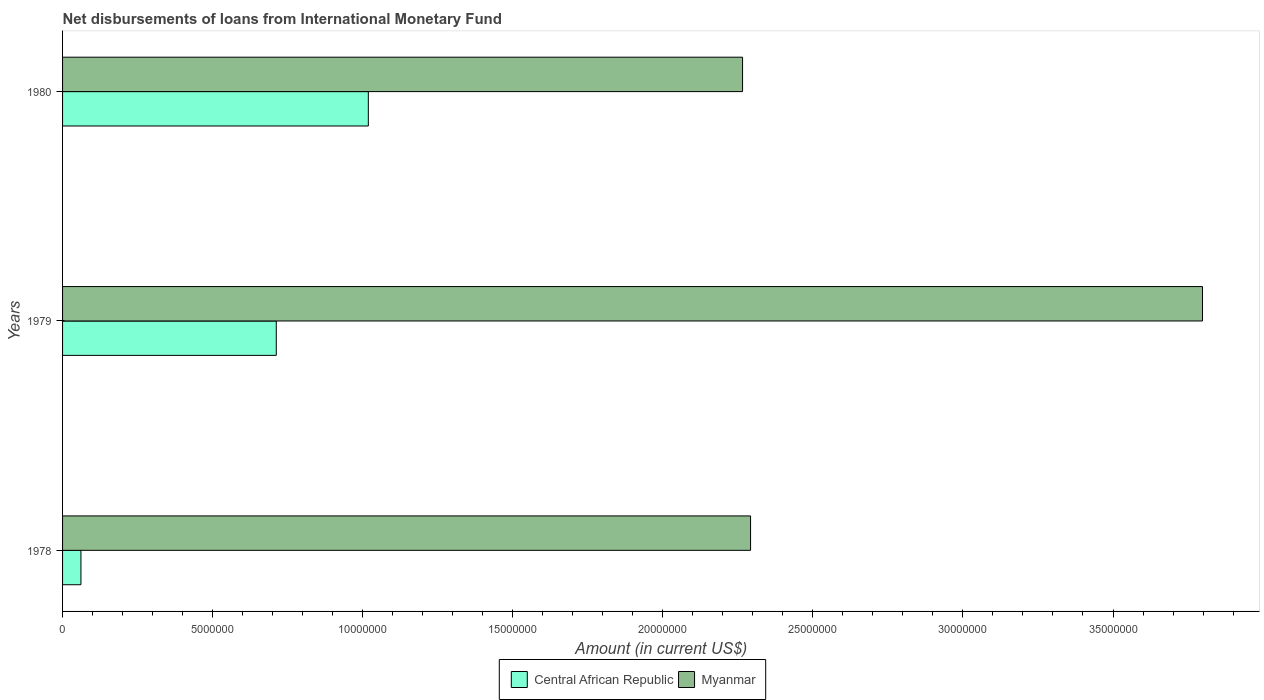How many groups of bars are there?
Offer a terse response. 3. How many bars are there on the 3rd tick from the bottom?
Provide a succinct answer. 2. What is the label of the 2nd group of bars from the top?
Offer a very short reply. 1979. What is the amount of loans disbursed in Central African Republic in 1978?
Your answer should be very brief. 6.12e+05. Across all years, what is the maximum amount of loans disbursed in Central African Republic?
Give a very brief answer. 1.02e+07. Across all years, what is the minimum amount of loans disbursed in Myanmar?
Offer a terse response. 2.27e+07. In which year was the amount of loans disbursed in Myanmar maximum?
Offer a very short reply. 1979. What is the total amount of loans disbursed in Central African Republic in the graph?
Your answer should be compact. 1.79e+07. What is the difference between the amount of loans disbursed in Myanmar in 1978 and that in 1979?
Provide a short and direct response. -1.51e+07. What is the difference between the amount of loans disbursed in Myanmar in 1980 and the amount of loans disbursed in Central African Republic in 1979?
Your answer should be very brief. 1.55e+07. What is the average amount of loans disbursed in Myanmar per year?
Give a very brief answer. 2.79e+07. In the year 1978, what is the difference between the amount of loans disbursed in Central African Republic and amount of loans disbursed in Myanmar?
Provide a short and direct response. -2.23e+07. In how many years, is the amount of loans disbursed in Myanmar greater than 30000000 US$?
Your answer should be compact. 1. What is the ratio of the amount of loans disbursed in Myanmar in 1978 to that in 1980?
Offer a very short reply. 1.01. What is the difference between the highest and the second highest amount of loans disbursed in Myanmar?
Offer a terse response. 1.51e+07. What is the difference between the highest and the lowest amount of loans disbursed in Central African Republic?
Provide a short and direct response. 9.58e+06. Is the sum of the amount of loans disbursed in Central African Republic in 1979 and 1980 greater than the maximum amount of loans disbursed in Myanmar across all years?
Offer a very short reply. No. What does the 2nd bar from the top in 1979 represents?
Provide a short and direct response. Central African Republic. What does the 2nd bar from the bottom in 1979 represents?
Your answer should be very brief. Myanmar. How many bars are there?
Make the answer very short. 6. Are all the bars in the graph horizontal?
Ensure brevity in your answer.  Yes. Are the values on the major ticks of X-axis written in scientific E-notation?
Give a very brief answer. No. Does the graph contain any zero values?
Provide a short and direct response. No. Does the graph contain grids?
Offer a terse response. No. How many legend labels are there?
Give a very brief answer. 2. How are the legend labels stacked?
Make the answer very short. Horizontal. What is the title of the graph?
Your answer should be very brief. Net disbursements of loans from International Monetary Fund. Does "Arab World" appear as one of the legend labels in the graph?
Make the answer very short. No. What is the label or title of the X-axis?
Your answer should be very brief. Amount (in current US$). What is the Amount (in current US$) of Central African Republic in 1978?
Provide a short and direct response. 6.12e+05. What is the Amount (in current US$) in Myanmar in 1978?
Offer a very short reply. 2.29e+07. What is the Amount (in current US$) in Central African Republic in 1979?
Offer a terse response. 7.12e+06. What is the Amount (in current US$) in Myanmar in 1979?
Offer a very short reply. 3.80e+07. What is the Amount (in current US$) of Central African Republic in 1980?
Ensure brevity in your answer.  1.02e+07. What is the Amount (in current US$) of Myanmar in 1980?
Ensure brevity in your answer.  2.27e+07. Across all years, what is the maximum Amount (in current US$) in Central African Republic?
Make the answer very short. 1.02e+07. Across all years, what is the maximum Amount (in current US$) in Myanmar?
Your answer should be very brief. 3.80e+07. Across all years, what is the minimum Amount (in current US$) in Central African Republic?
Offer a terse response. 6.12e+05. Across all years, what is the minimum Amount (in current US$) of Myanmar?
Give a very brief answer. 2.27e+07. What is the total Amount (in current US$) of Central African Republic in the graph?
Offer a very short reply. 1.79e+07. What is the total Amount (in current US$) in Myanmar in the graph?
Provide a succinct answer. 8.36e+07. What is the difference between the Amount (in current US$) of Central African Republic in 1978 and that in 1979?
Your answer should be very brief. -6.51e+06. What is the difference between the Amount (in current US$) in Myanmar in 1978 and that in 1979?
Your answer should be very brief. -1.51e+07. What is the difference between the Amount (in current US$) in Central African Republic in 1978 and that in 1980?
Provide a short and direct response. -9.58e+06. What is the difference between the Amount (in current US$) of Myanmar in 1978 and that in 1980?
Make the answer very short. 2.67e+05. What is the difference between the Amount (in current US$) of Central African Republic in 1979 and that in 1980?
Offer a terse response. -3.07e+06. What is the difference between the Amount (in current US$) of Myanmar in 1979 and that in 1980?
Provide a short and direct response. 1.53e+07. What is the difference between the Amount (in current US$) of Central African Republic in 1978 and the Amount (in current US$) of Myanmar in 1979?
Offer a terse response. -3.74e+07. What is the difference between the Amount (in current US$) of Central African Republic in 1978 and the Amount (in current US$) of Myanmar in 1980?
Give a very brief answer. -2.20e+07. What is the difference between the Amount (in current US$) of Central African Republic in 1979 and the Amount (in current US$) of Myanmar in 1980?
Your response must be concise. -1.55e+07. What is the average Amount (in current US$) of Central African Republic per year?
Offer a very short reply. 5.97e+06. What is the average Amount (in current US$) of Myanmar per year?
Keep it short and to the point. 2.79e+07. In the year 1978, what is the difference between the Amount (in current US$) in Central African Republic and Amount (in current US$) in Myanmar?
Provide a short and direct response. -2.23e+07. In the year 1979, what is the difference between the Amount (in current US$) of Central African Republic and Amount (in current US$) of Myanmar?
Offer a terse response. -3.09e+07. In the year 1980, what is the difference between the Amount (in current US$) of Central African Republic and Amount (in current US$) of Myanmar?
Your response must be concise. -1.25e+07. What is the ratio of the Amount (in current US$) of Central African Republic in 1978 to that in 1979?
Provide a succinct answer. 0.09. What is the ratio of the Amount (in current US$) in Myanmar in 1978 to that in 1979?
Offer a very short reply. 0.6. What is the ratio of the Amount (in current US$) of Central African Republic in 1978 to that in 1980?
Make the answer very short. 0.06. What is the ratio of the Amount (in current US$) of Myanmar in 1978 to that in 1980?
Your answer should be compact. 1.01. What is the ratio of the Amount (in current US$) of Central African Republic in 1979 to that in 1980?
Keep it short and to the point. 0.7. What is the ratio of the Amount (in current US$) of Myanmar in 1979 to that in 1980?
Your answer should be very brief. 1.68. What is the difference between the highest and the second highest Amount (in current US$) in Central African Republic?
Provide a short and direct response. 3.07e+06. What is the difference between the highest and the second highest Amount (in current US$) in Myanmar?
Make the answer very short. 1.51e+07. What is the difference between the highest and the lowest Amount (in current US$) of Central African Republic?
Your response must be concise. 9.58e+06. What is the difference between the highest and the lowest Amount (in current US$) in Myanmar?
Provide a short and direct response. 1.53e+07. 